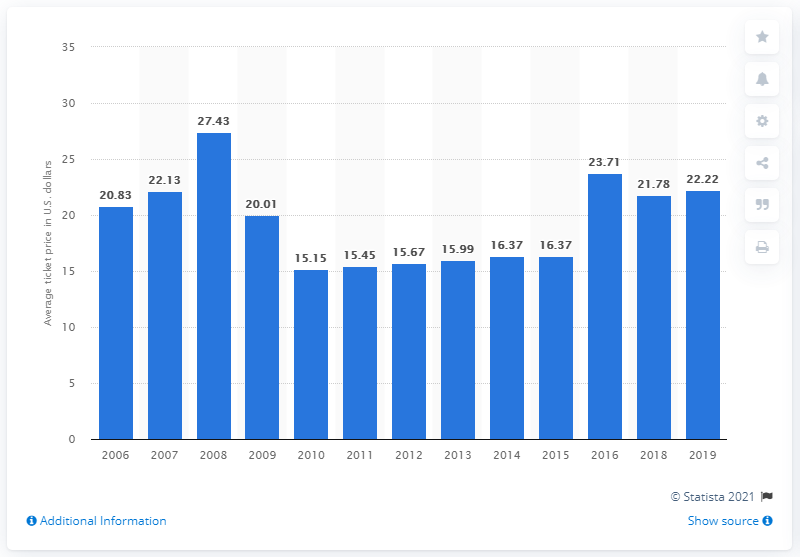Draw attention to some important aspects in this diagram. The average ticket price for San Diego Padres games in 2019 was $22.22. 